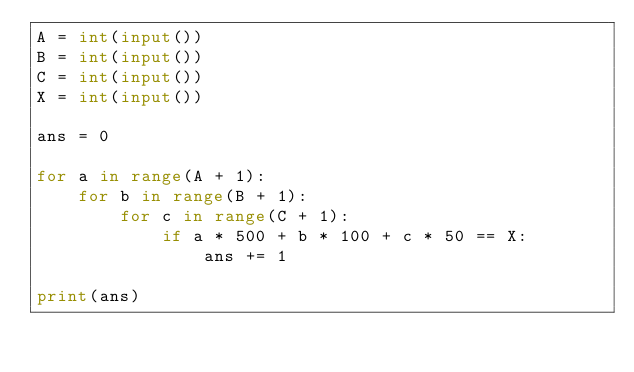Convert code to text. <code><loc_0><loc_0><loc_500><loc_500><_Python_>A = int(input())
B = int(input())
C = int(input())
X = int(input())

ans = 0

for a in range(A + 1):
    for b in range(B + 1):
        for c in range(C + 1):
            if a * 500 + b * 100 + c * 50 == X:
                ans += 1

print(ans)
</code> 